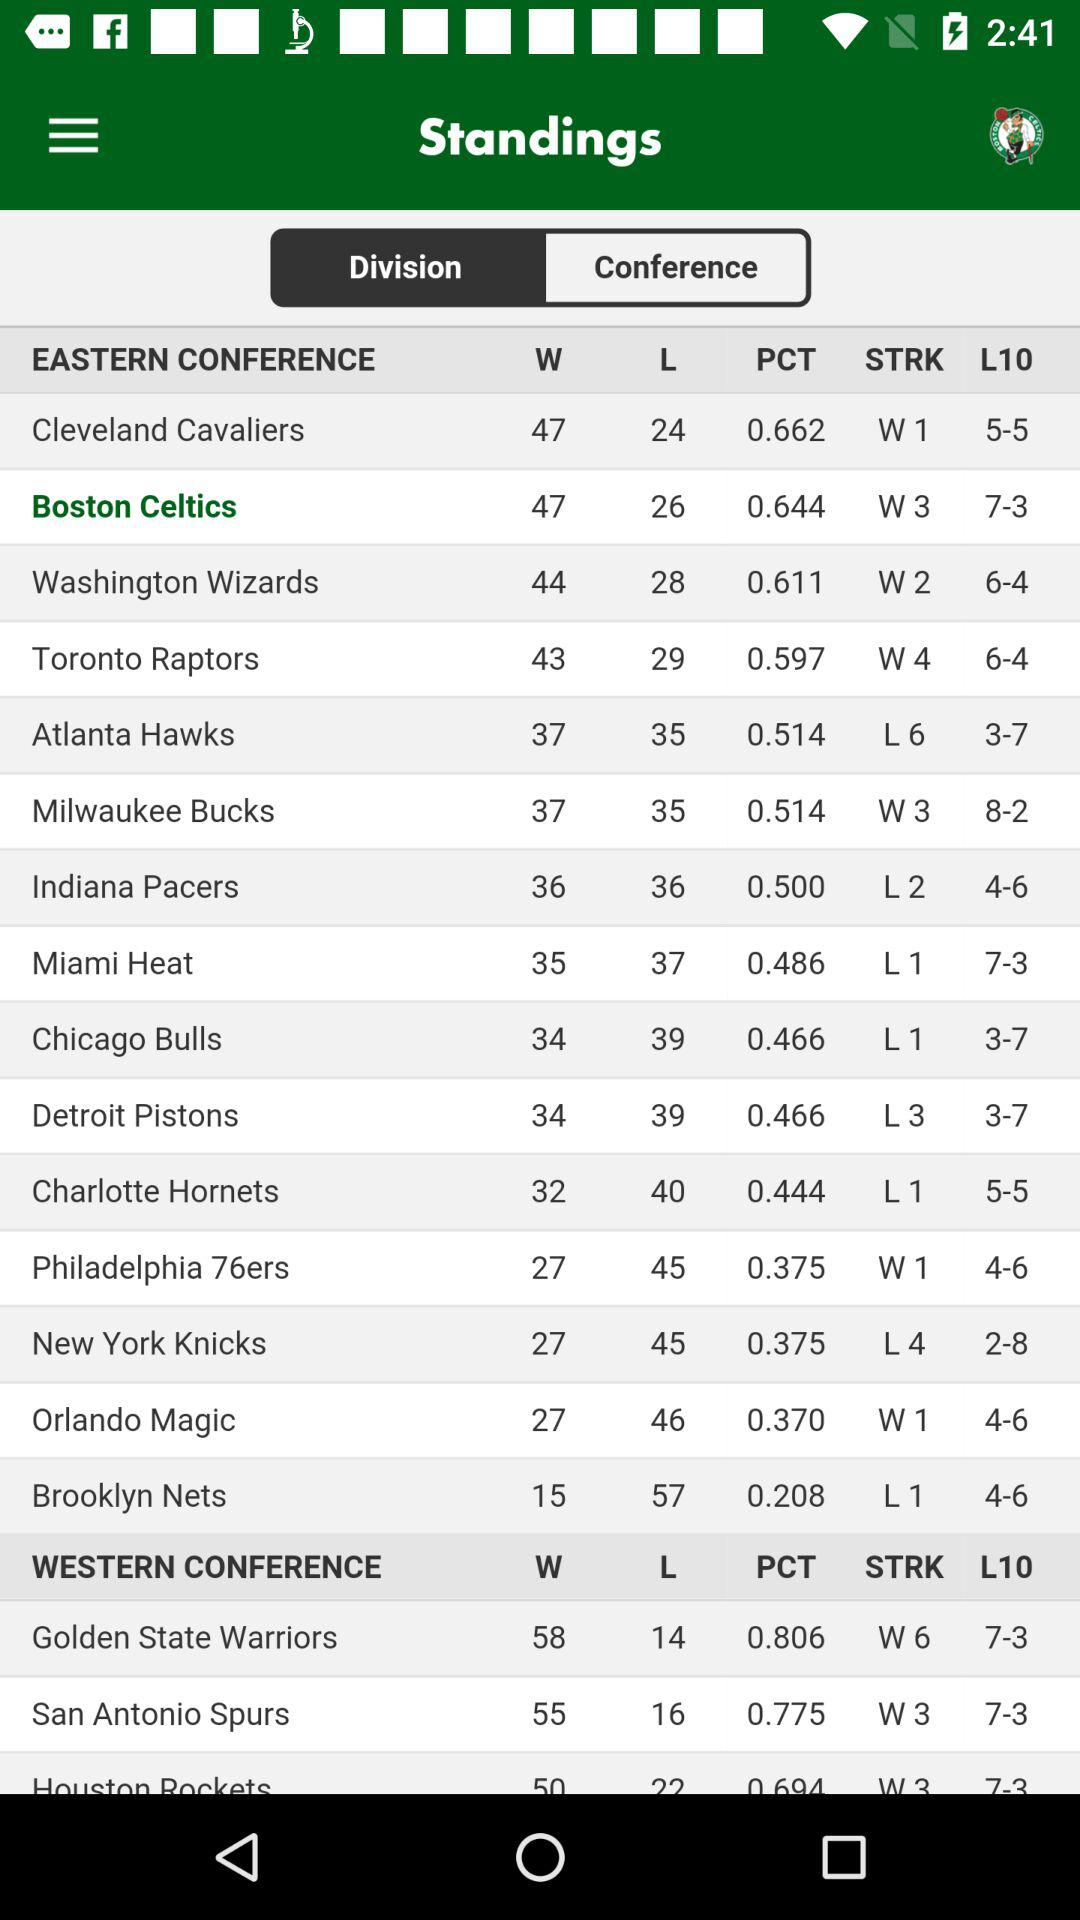What is the selected division?
When the provided information is insufficient, respond with <no answer>. <no answer> 